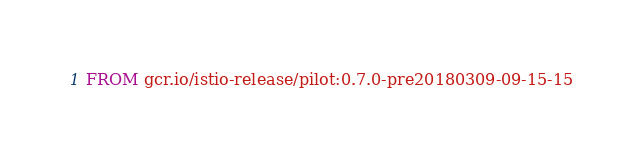Convert code to text. <code><loc_0><loc_0><loc_500><loc_500><_Dockerfile_>FROM gcr.io/istio-release/pilot:0.7.0-pre20180309-09-15-15
</code> 